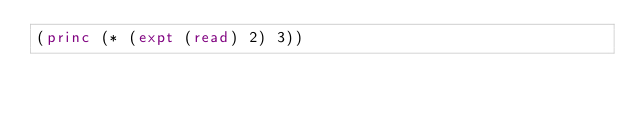<code> <loc_0><loc_0><loc_500><loc_500><_Lisp_>(princ (* (expt (read) 2) 3))</code> 